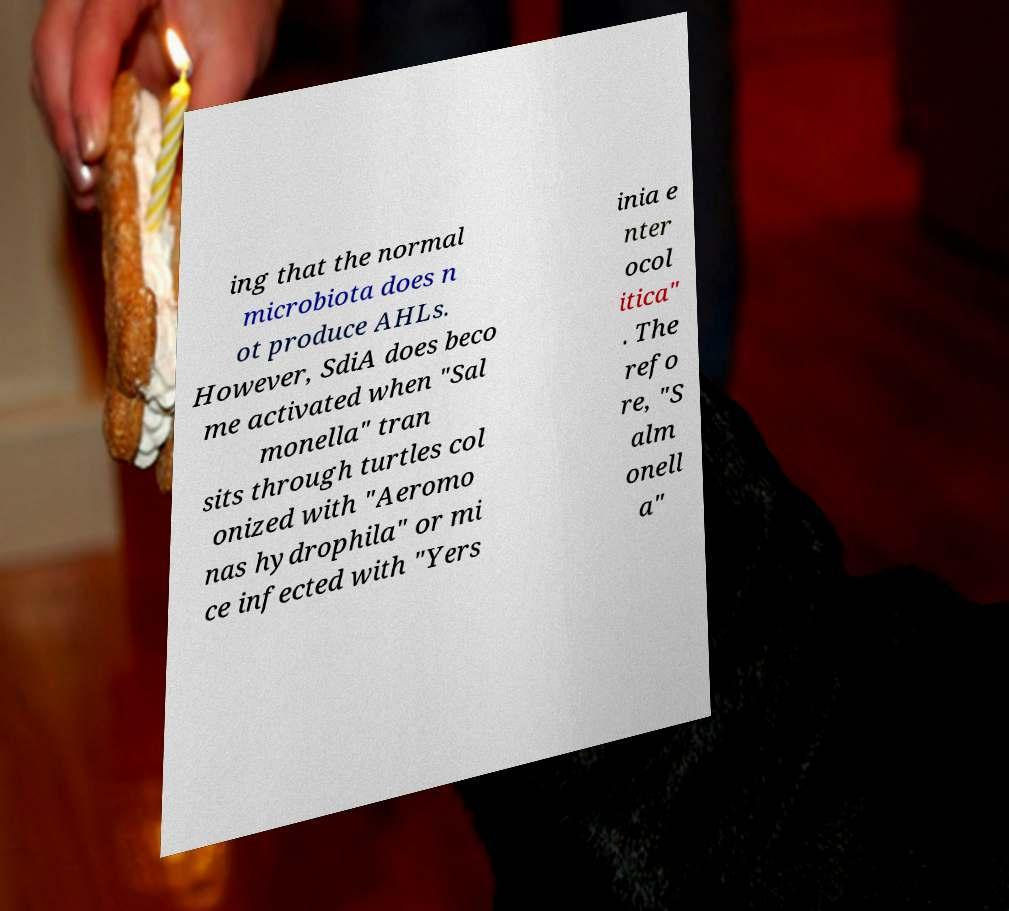Could you extract and type out the text from this image? ing that the normal microbiota does n ot produce AHLs. However, SdiA does beco me activated when "Sal monella" tran sits through turtles col onized with "Aeromo nas hydrophila" or mi ce infected with "Yers inia e nter ocol itica" . The refo re, "S alm onell a" 